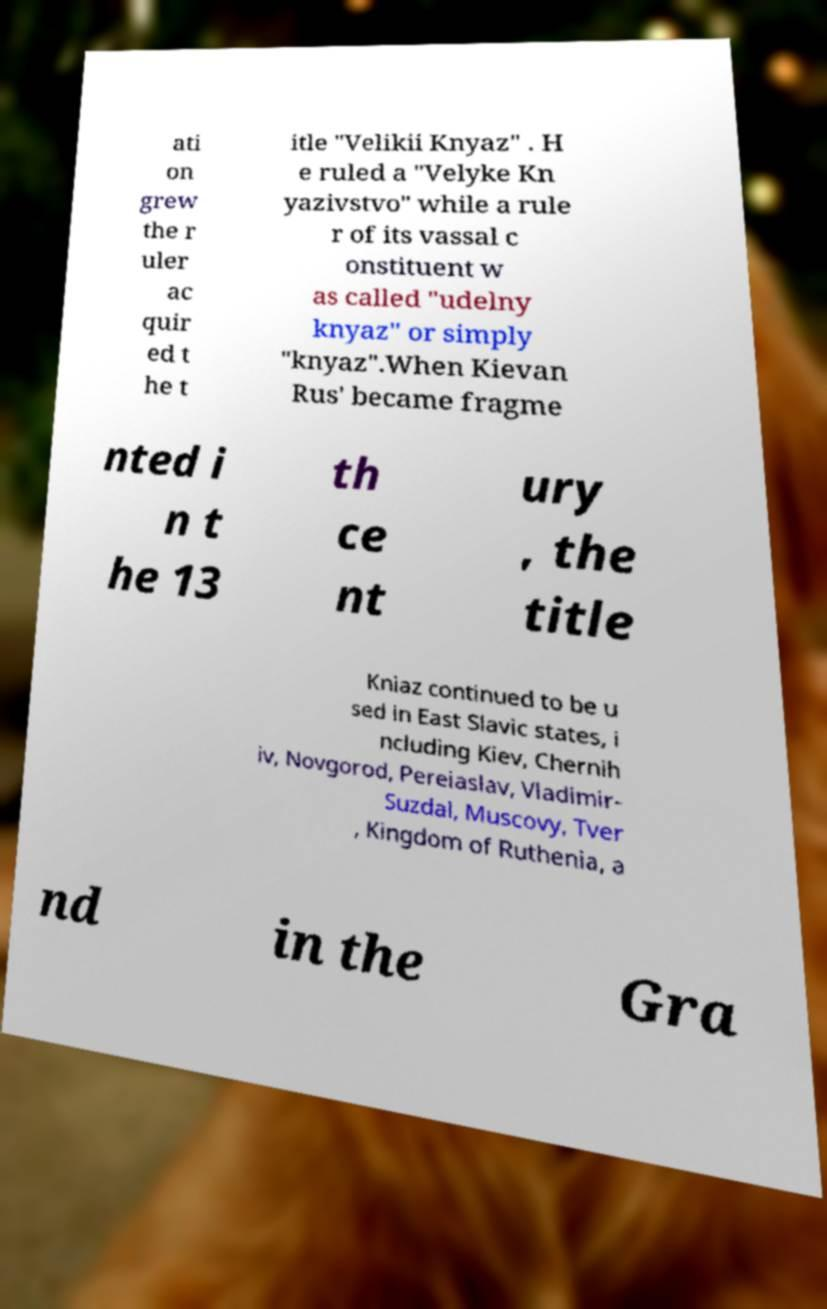Please identify and transcribe the text found in this image. ati on grew the r uler ac quir ed t he t itle "Velikii Knyaz" . H e ruled a "Velyke Kn yazivstvo" while a rule r of its vassal c onstituent w as called "udelny knyaz" or simply "knyaz".When Kievan Rus' became fragme nted i n t he 13 th ce nt ury , the title Kniaz continued to be u sed in East Slavic states, i ncluding Kiev, Chernih iv, Novgorod, Pereiaslav, Vladimir- Suzdal, Muscovy, Tver , Kingdom of Ruthenia, a nd in the Gra 